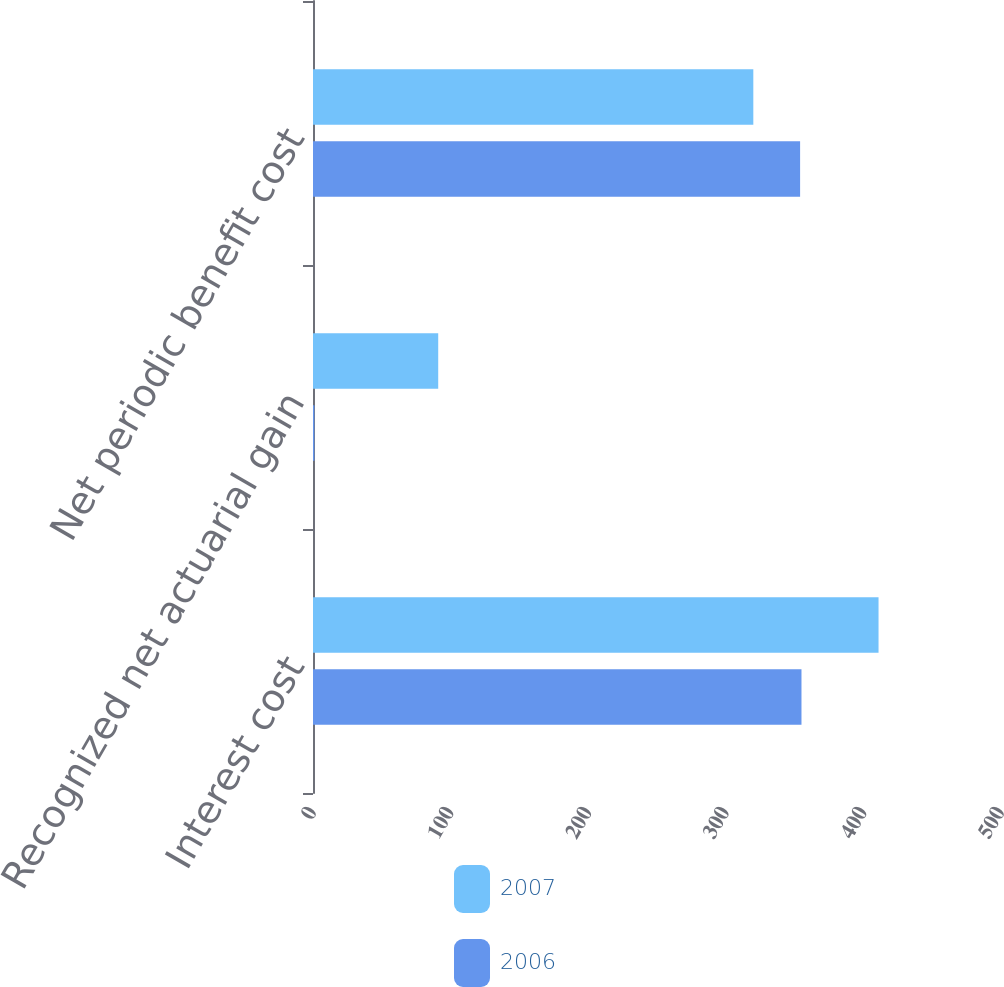Convert chart. <chart><loc_0><loc_0><loc_500><loc_500><stacked_bar_chart><ecel><fcel>Interest cost<fcel>Recognized net actuarial gain<fcel>Net periodic benefit cost<nl><fcel>2007<fcel>411<fcel>91<fcel>320<nl><fcel>2006<fcel>355<fcel>1<fcel>354<nl></chart> 